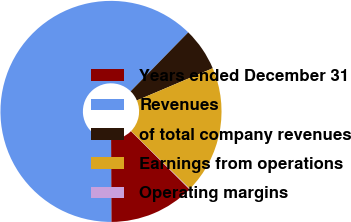Convert chart to OTSL. <chart><loc_0><loc_0><loc_500><loc_500><pie_chart><fcel>Years ended December 31<fcel>Revenues<fcel>of total company revenues<fcel>Earnings from operations<fcel>Operating margins<nl><fcel>12.52%<fcel>62.36%<fcel>6.3%<fcel>18.75%<fcel>0.07%<nl></chart> 